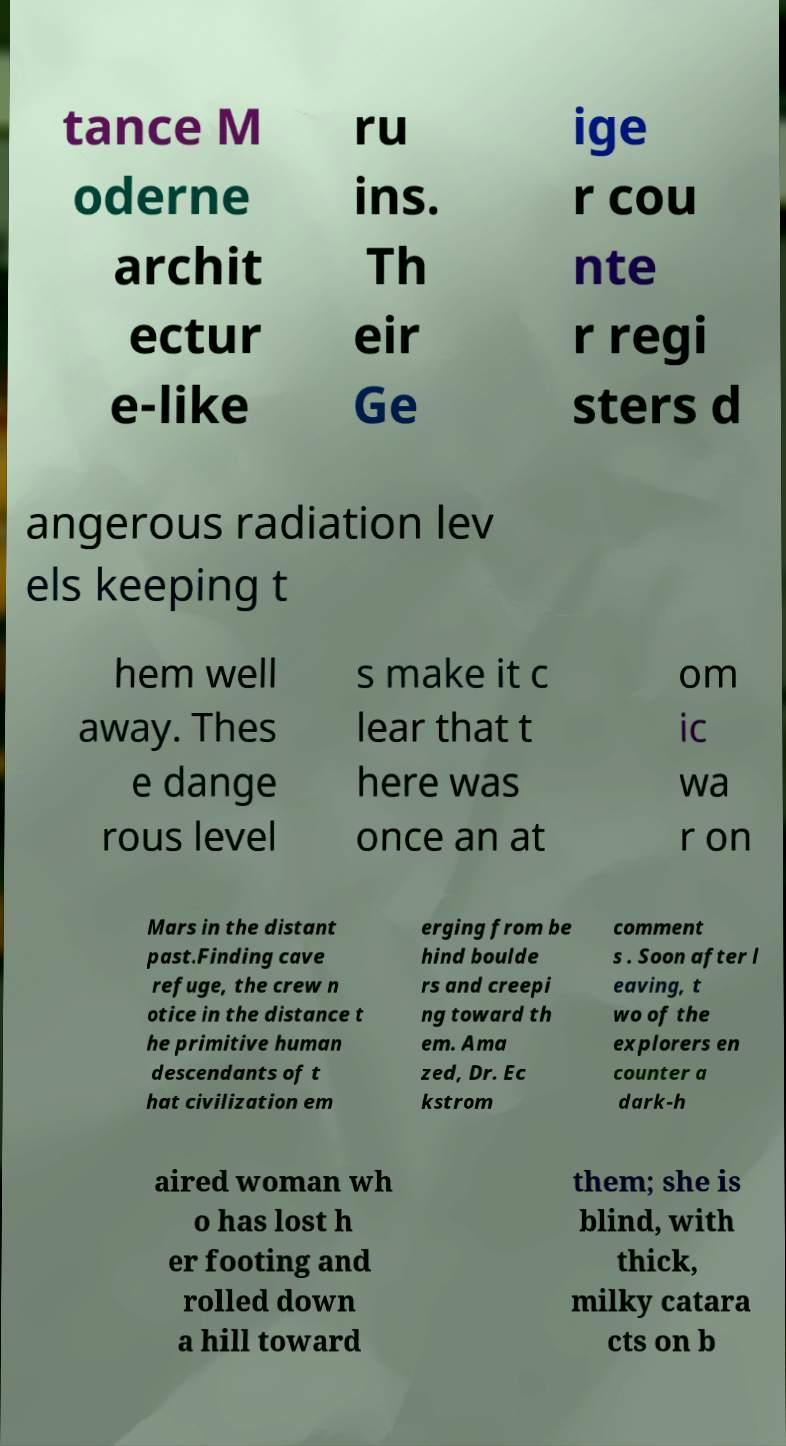Could you assist in decoding the text presented in this image and type it out clearly? tance M oderne archit ectur e-like ru ins. Th eir Ge ige r cou nte r regi sters d angerous radiation lev els keeping t hem well away. Thes e dange rous level s make it c lear that t here was once an at om ic wa r on Mars in the distant past.Finding cave refuge, the crew n otice in the distance t he primitive human descendants of t hat civilization em erging from be hind boulde rs and creepi ng toward th em. Ama zed, Dr. Ec kstrom comment s . Soon after l eaving, t wo of the explorers en counter a dark-h aired woman wh o has lost h er footing and rolled down a hill toward them; she is blind, with thick, milky catara cts on b 